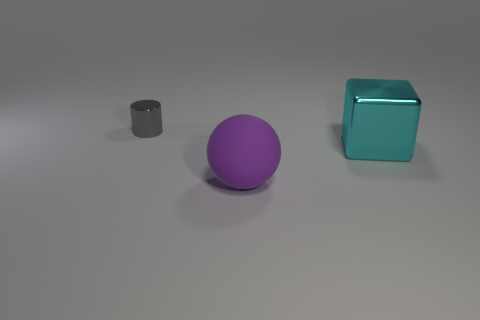Add 2 cyan objects. How many objects exist? 5 Subtract all blocks. How many objects are left? 2 Subtract all yellow blocks. How many blue balls are left? 0 Subtract all big things. Subtract all purple spheres. How many objects are left? 0 Add 3 large rubber balls. How many large rubber balls are left? 4 Add 3 purple matte spheres. How many purple matte spheres exist? 4 Subtract 0 yellow cubes. How many objects are left? 3 Subtract 1 balls. How many balls are left? 0 Subtract all gray spheres. Subtract all red cylinders. How many spheres are left? 1 